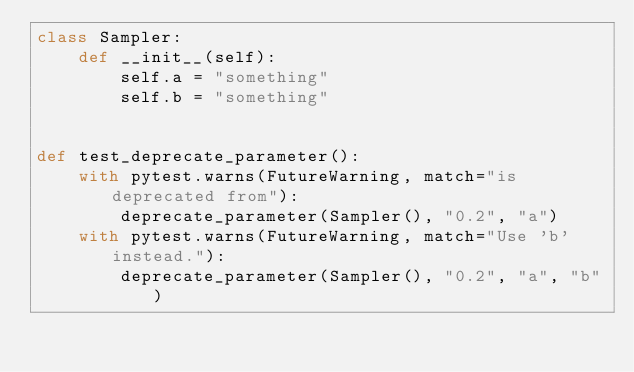<code> <loc_0><loc_0><loc_500><loc_500><_Python_>class Sampler:
    def __init__(self):
        self.a = "something"
        self.b = "something"


def test_deprecate_parameter():
    with pytest.warns(FutureWarning, match="is deprecated from"):
        deprecate_parameter(Sampler(), "0.2", "a")
    with pytest.warns(FutureWarning, match="Use 'b' instead."):
        deprecate_parameter(Sampler(), "0.2", "a", "b")
</code> 